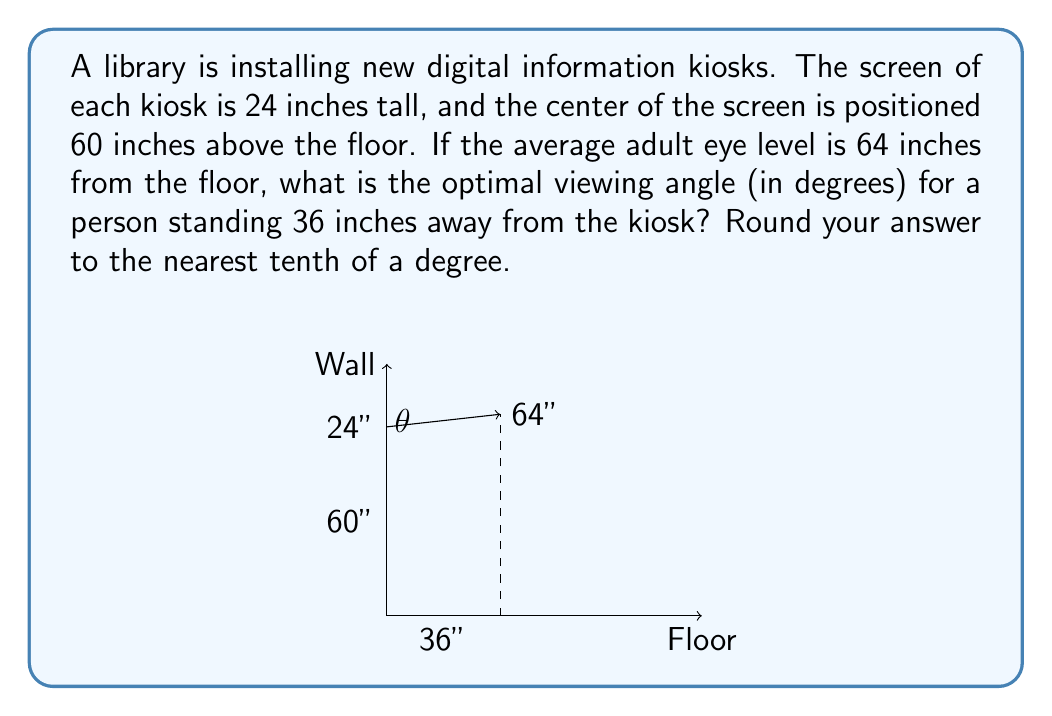Show me your answer to this math problem. To solve this problem, we'll use trigonometry to find the optimal viewing angle. Let's break it down step by step:

1) First, we need to find the vertical distance between the center of the screen and the average eye level:
   $64" - 60" = 4"$

2) Now we have a right triangle with the following measurements:
   - Base (adjacent to the angle we're looking for): 36"
   - Height (opposite to the angle): 4"

3) To find the angle, we can use the arctangent function:
   $\theta = \arctan(\frac{\text{opposite}}{\text{adjacent}})$

4) Plugging in our values:
   $\theta = \arctan(\frac{4}{36})$

5) Simplifying the fraction:
   $\theta = \arctan(\frac{1}{9})$

6) Using a calculator or computer to evaluate this:
   $\theta \approx 6.34°$

7) Rounding to the nearest tenth of a degree:
   $\theta \approx 6.3°$

This angle represents the optimal viewing angle from the center of the screen. However, we should consider that the screen is 24 inches tall, so the actual viewing angles will range from slightly below to slightly above this central angle, providing a comfortable viewing experience for users of various heights.
Answer: The optimal viewing angle is approximately $6.3°$. 